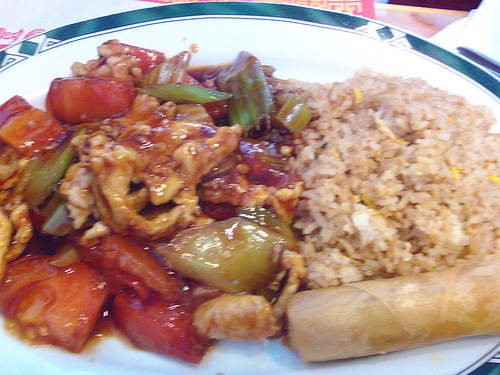<image>
Is there a rice in front of the table? No. The rice is not in front of the table. The spatial positioning shows a different relationship between these objects. 